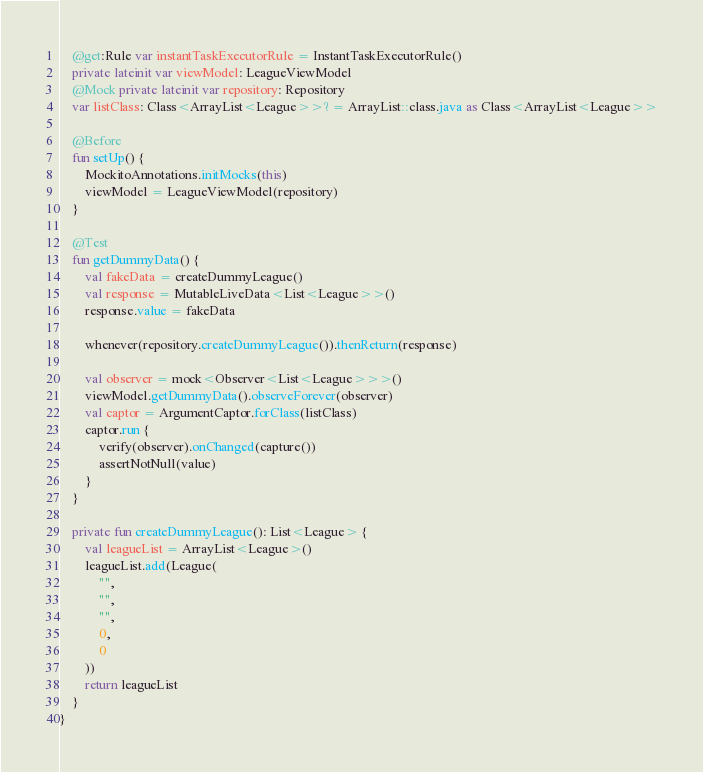<code> <loc_0><loc_0><loc_500><loc_500><_Kotlin_>
    @get:Rule var instantTaskExecutorRule = InstantTaskExecutorRule()
    private lateinit var viewModel: LeagueViewModel
    @Mock private lateinit var repository: Repository
    var listClass: Class<ArrayList<League>>? = ArrayList::class.java as Class<ArrayList<League>>

    @Before
    fun setUp() {
        MockitoAnnotations.initMocks(this)
        viewModel = LeagueViewModel(repository)
    }

    @Test
    fun getDummyData() {
        val fakeData = createDummyLeague()
        val response = MutableLiveData<List<League>>()
        response.value = fakeData

        whenever(repository.createDummyLeague()).thenReturn(response)

        val observer = mock<Observer<List<League>>>()
        viewModel.getDummyData().observeForever(observer)
        val captor = ArgumentCaptor.forClass(listClass)
        captor.run {
            verify(observer).onChanged(capture())
            assertNotNull(value)
        }
    }

    private fun createDummyLeague(): List<League> {
        val leagueList = ArrayList<League>()
        leagueList.add(League(
            "",
            "",
            "",
            0,
            0
        ))
        return leagueList
    }
}</code> 